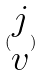Convert formula to latex. <formula><loc_0><loc_0><loc_500><loc_500>( \begin{matrix} j \\ v \end{matrix} )</formula> 